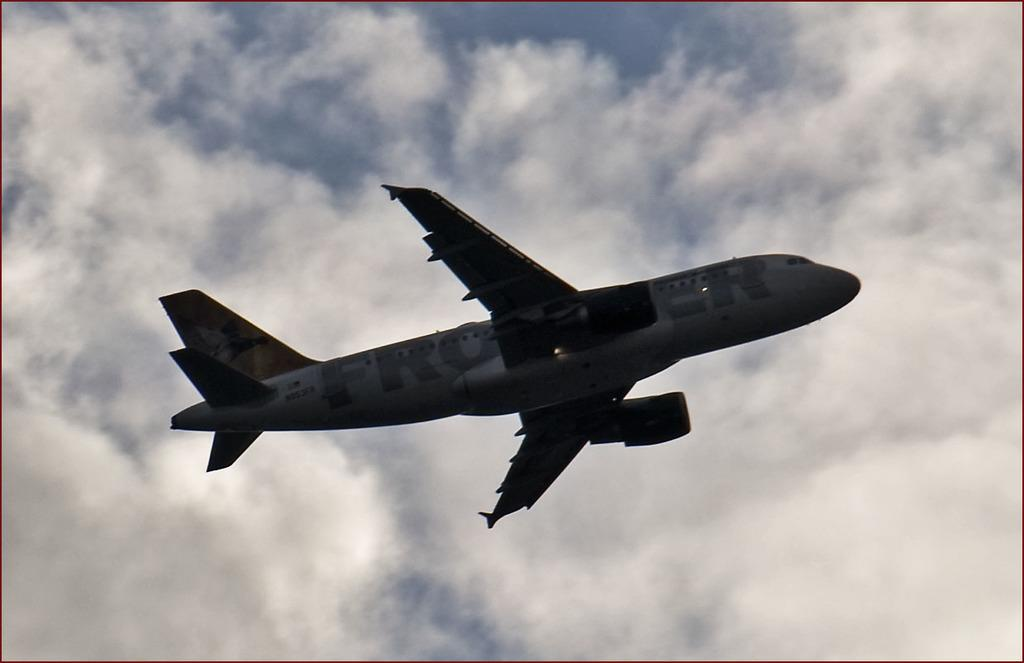<image>
Render a clear and concise summary of the photo. A Frontier plane flies above on a cloudy day. 